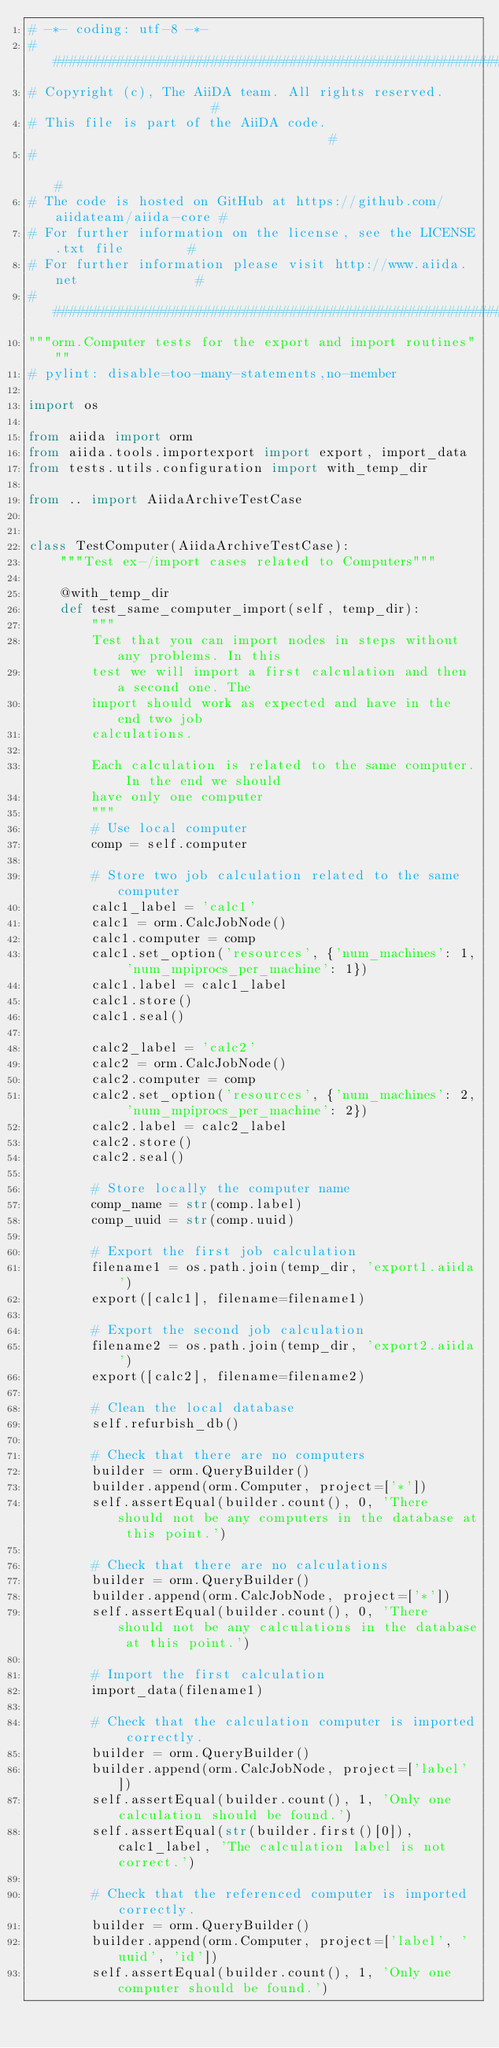Convert code to text. <code><loc_0><loc_0><loc_500><loc_500><_Python_># -*- coding: utf-8 -*-
###########################################################################
# Copyright (c), The AiiDA team. All rights reserved.                     #
# This file is part of the AiiDA code.                                    #
#                                                                         #
# The code is hosted on GitHub at https://github.com/aiidateam/aiida-core #
# For further information on the license, see the LICENSE.txt file        #
# For further information please visit http://www.aiida.net               #
###########################################################################
"""orm.Computer tests for the export and import routines"""
# pylint: disable=too-many-statements,no-member

import os

from aiida import orm
from aiida.tools.importexport import export, import_data
from tests.utils.configuration import with_temp_dir

from .. import AiidaArchiveTestCase


class TestComputer(AiidaArchiveTestCase):
    """Test ex-/import cases related to Computers"""

    @with_temp_dir
    def test_same_computer_import(self, temp_dir):
        """
        Test that you can import nodes in steps without any problems. In this
        test we will import a first calculation and then a second one. The
        import should work as expected and have in the end two job
        calculations.

        Each calculation is related to the same computer. In the end we should
        have only one computer
        """
        # Use local computer
        comp = self.computer

        # Store two job calculation related to the same computer
        calc1_label = 'calc1'
        calc1 = orm.CalcJobNode()
        calc1.computer = comp
        calc1.set_option('resources', {'num_machines': 1, 'num_mpiprocs_per_machine': 1})
        calc1.label = calc1_label
        calc1.store()
        calc1.seal()

        calc2_label = 'calc2'
        calc2 = orm.CalcJobNode()
        calc2.computer = comp
        calc2.set_option('resources', {'num_machines': 2, 'num_mpiprocs_per_machine': 2})
        calc2.label = calc2_label
        calc2.store()
        calc2.seal()

        # Store locally the computer name
        comp_name = str(comp.label)
        comp_uuid = str(comp.uuid)

        # Export the first job calculation
        filename1 = os.path.join(temp_dir, 'export1.aiida')
        export([calc1], filename=filename1)

        # Export the second job calculation
        filename2 = os.path.join(temp_dir, 'export2.aiida')
        export([calc2], filename=filename2)

        # Clean the local database
        self.refurbish_db()

        # Check that there are no computers
        builder = orm.QueryBuilder()
        builder.append(orm.Computer, project=['*'])
        self.assertEqual(builder.count(), 0, 'There should not be any computers in the database at this point.')

        # Check that there are no calculations
        builder = orm.QueryBuilder()
        builder.append(orm.CalcJobNode, project=['*'])
        self.assertEqual(builder.count(), 0, 'There should not be any calculations in the database at this point.')

        # Import the first calculation
        import_data(filename1)

        # Check that the calculation computer is imported correctly.
        builder = orm.QueryBuilder()
        builder.append(orm.CalcJobNode, project=['label'])
        self.assertEqual(builder.count(), 1, 'Only one calculation should be found.')
        self.assertEqual(str(builder.first()[0]), calc1_label, 'The calculation label is not correct.')

        # Check that the referenced computer is imported correctly.
        builder = orm.QueryBuilder()
        builder.append(orm.Computer, project=['label', 'uuid', 'id'])
        self.assertEqual(builder.count(), 1, 'Only one computer should be found.')</code> 